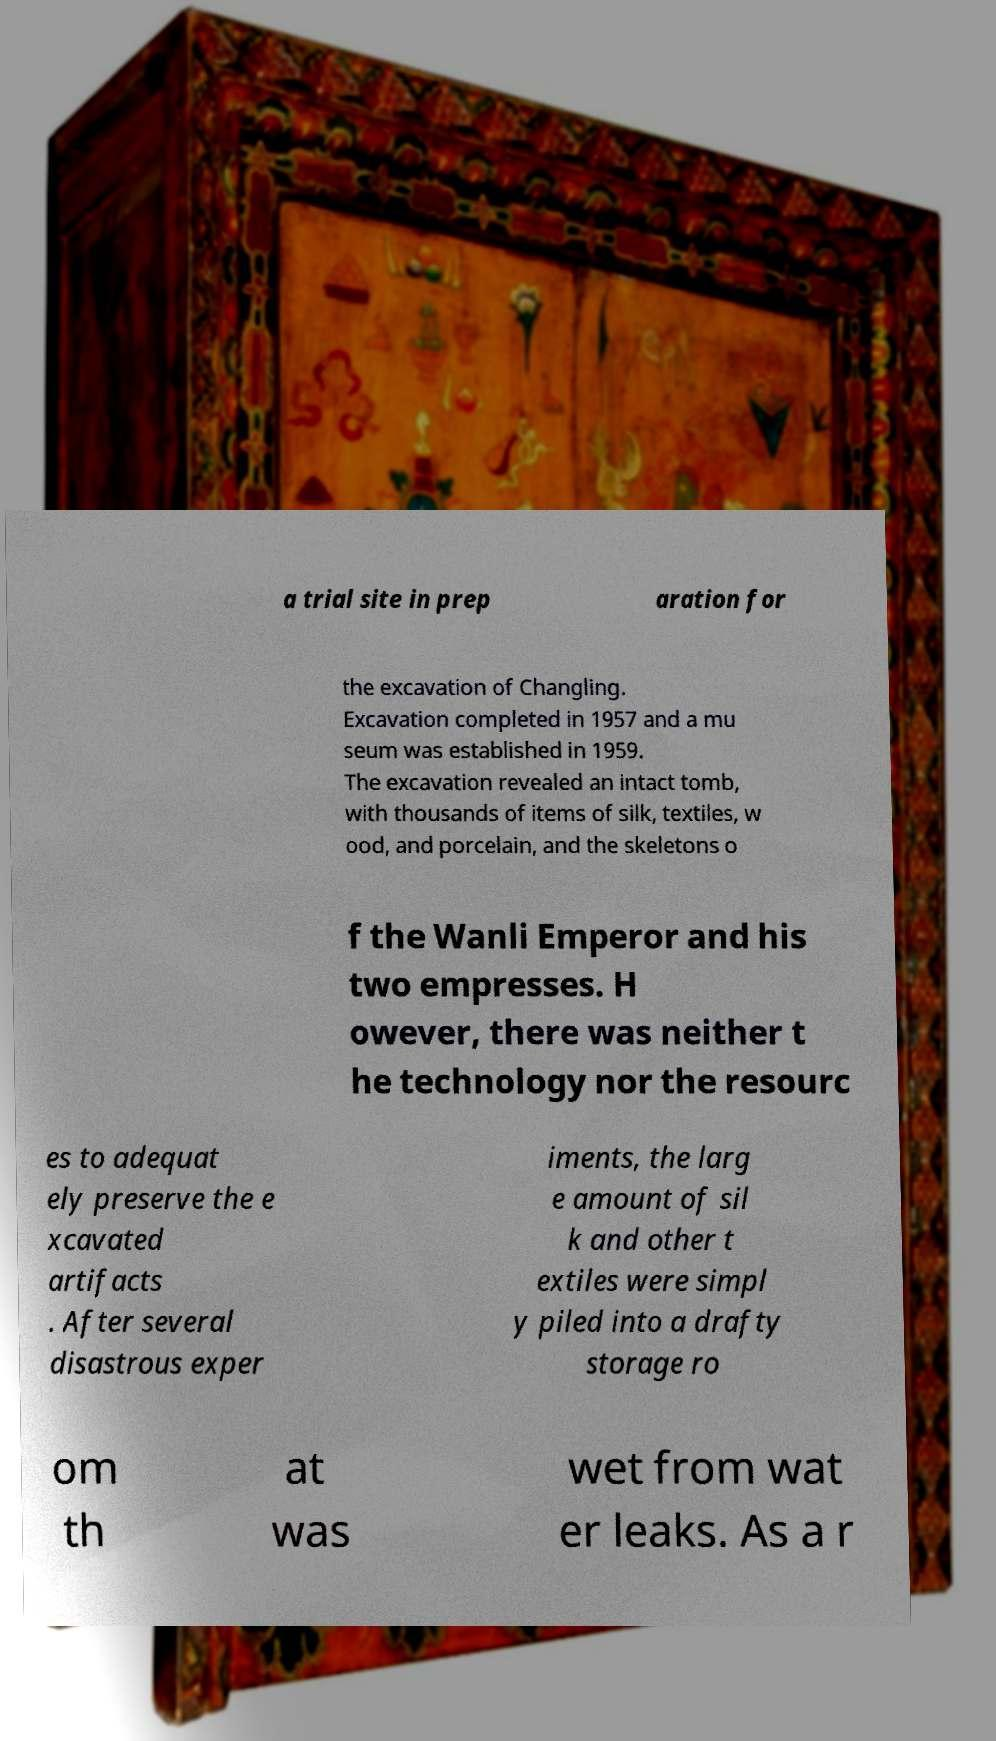Can you read and provide the text displayed in the image?This photo seems to have some interesting text. Can you extract and type it out for me? a trial site in prep aration for the excavation of Changling. Excavation completed in 1957 and a mu seum was established in 1959. The excavation revealed an intact tomb, with thousands of items of silk, textiles, w ood, and porcelain, and the skeletons o f the Wanli Emperor and his two empresses. H owever, there was neither t he technology nor the resourc es to adequat ely preserve the e xcavated artifacts . After several disastrous exper iments, the larg e amount of sil k and other t extiles were simpl y piled into a drafty storage ro om th at was wet from wat er leaks. As a r 